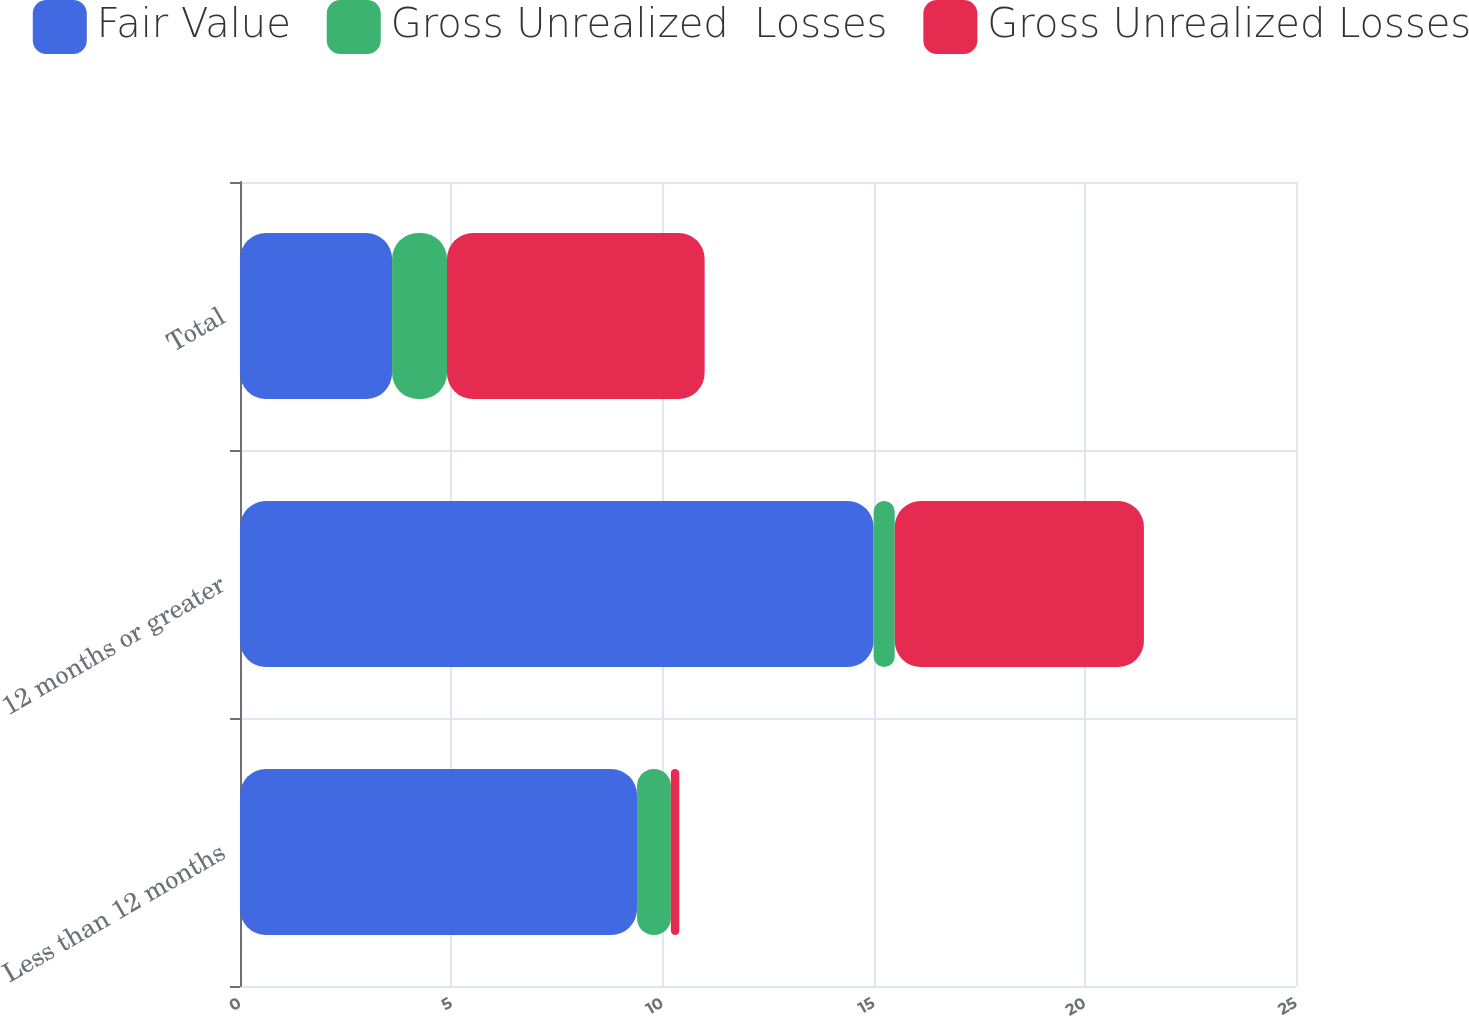Convert chart. <chart><loc_0><loc_0><loc_500><loc_500><stacked_bar_chart><ecel><fcel>Less than 12 months<fcel>12 months or greater<fcel>Total<nl><fcel>Fair Value<fcel>9.4<fcel>15<fcel>3.6<nl><fcel>Gross Unrealized  Losses<fcel>0.8<fcel>0.5<fcel>1.3<nl><fcel>Gross Unrealized Losses<fcel>0.2<fcel>5.9<fcel>6.1<nl></chart> 